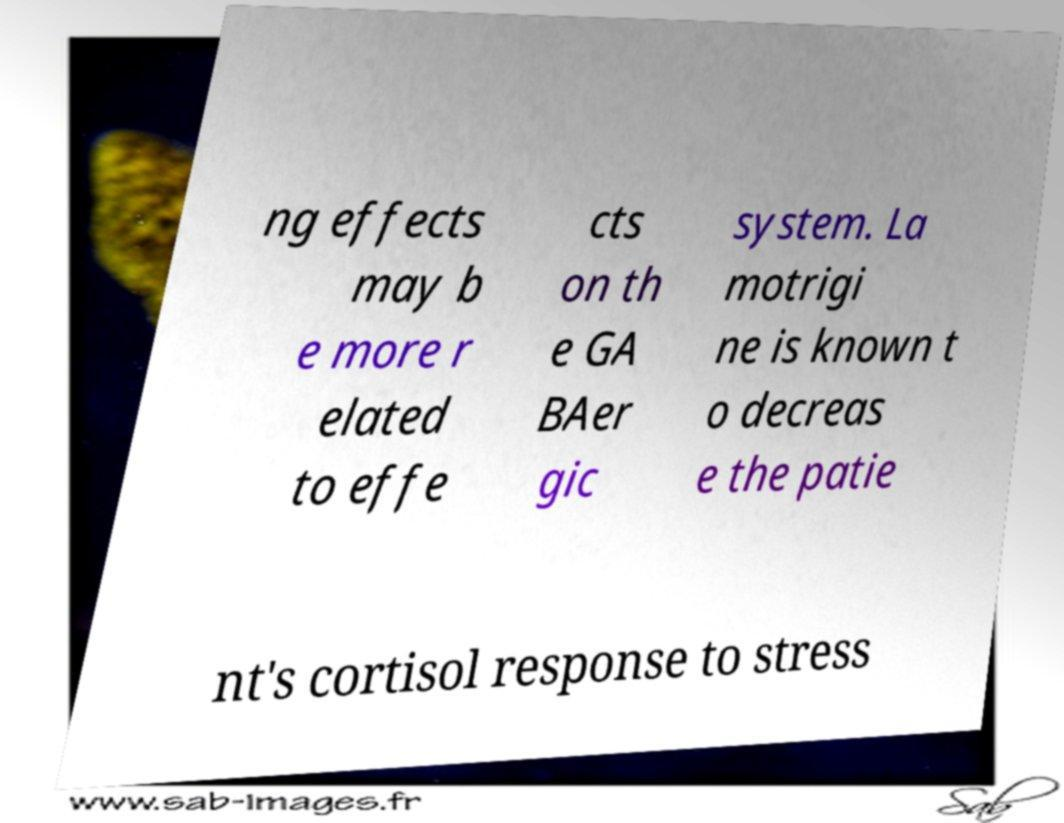Could you assist in decoding the text presented in this image and type it out clearly? ng effects may b e more r elated to effe cts on th e GA BAer gic system. La motrigi ne is known t o decreas e the patie nt's cortisol response to stress 